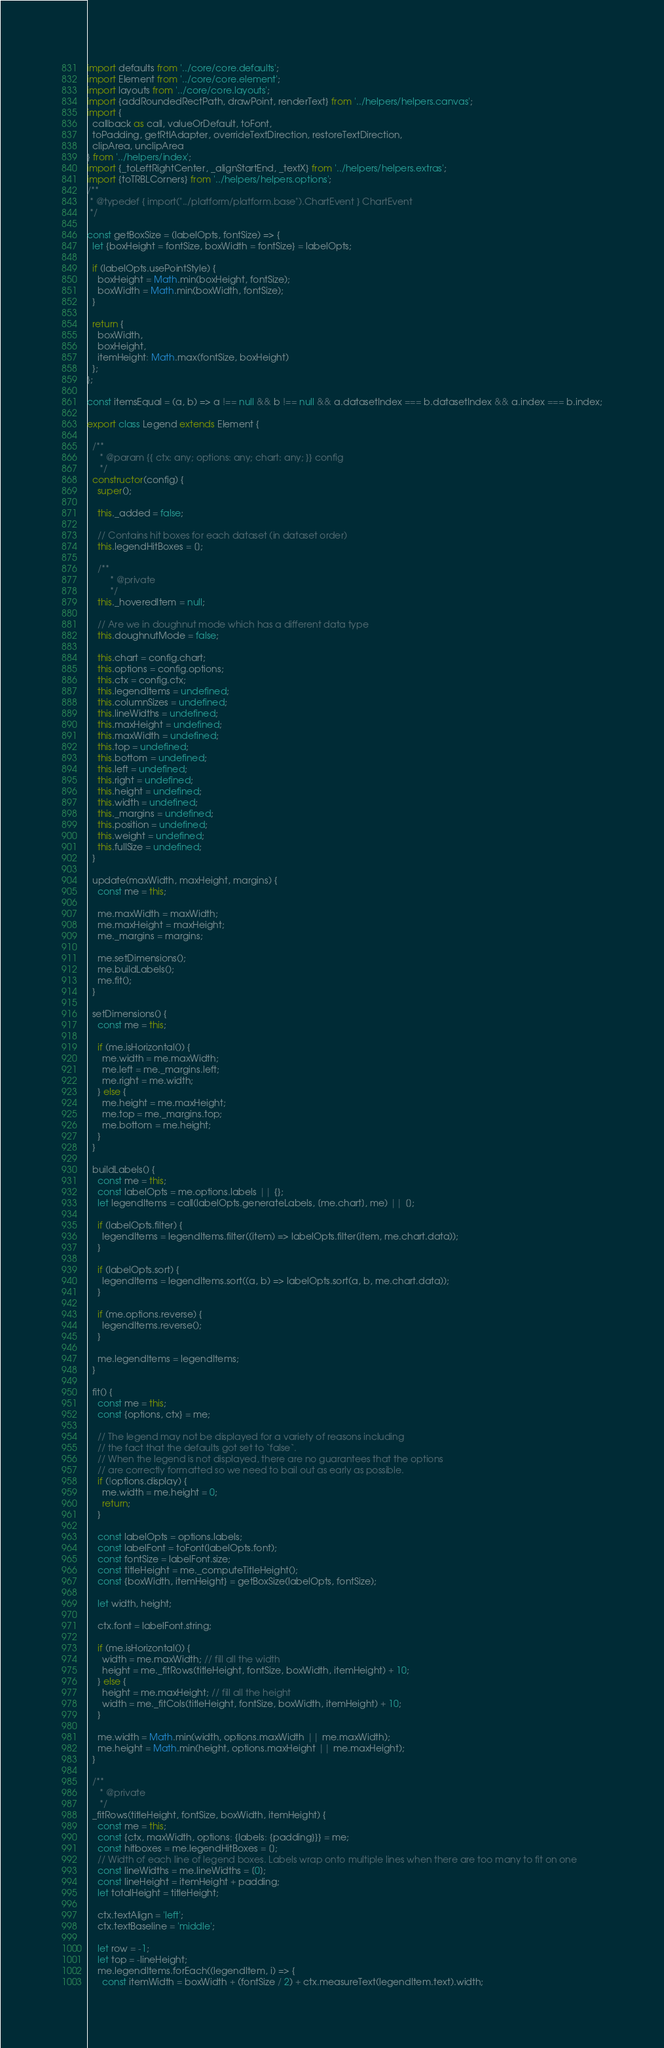<code> <loc_0><loc_0><loc_500><loc_500><_JavaScript_>import defaults from '../core/core.defaults';
import Element from '../core/core.element';
import layouts from '../core/core.layouts';
import {addRoundedRectPath, drawPoint, renderText} from '../helpers/helpers.canvas';
import {
  callback as call, valueOrDefault, toFont,
  toPadding, getRtlAdapter, overrideTextDirection, restoreTextDirection,
  clipArea, unclipArea
} from '../helpers/index';
import {_toLeftRightCenter, _alignStartEnd, _textX} from '../helpers/helpers.extras';
import {toTRBLCorners} from '../helpers/helpers.options';
/**
 * @typedef { import("../platform/platform.base").ChartEvent } ChartEvent
 */

const getBoxSize = (labelOpts, fontSize) => {
  let {boxHeight = fontSize, boxWidth = fontSize} = labelOpts;

  if (labelOpts.usePointStyle) {
    boxHeight = Math.min(boxHeight, fontSize);
    boxWidth = Math.min(boxWidth, fontSize);
  }

  return {
    boxWidth,
    boxHeight,
    itemHeight: Math.max(fontSize, boxHeight)
  };
};

const itemsEqual = (a, b) => a !== null && b !== null && a.datasetIndex === b.datasetIndex && a.index === b.index;

export class Legend extends Element {

  /**
	 * @param {{ ctx: any; options: any; chart: any; }} config
	 */
  constructor(config) {
    super();

    this._added = false;

    // Contains hit boxes for each dataset (in dataset order)
    this.legendHitBoxes = [];

    /**
 		 * @private
 		 */
    this._hoveredItem = null;

    // Are we in doughnut mode which has a different data type
    this.doughnutMode = false;

    this.chart = config.chart;
    this.options = config.options;
    this.ctx = config.ctx;
    this.legendItems = undefined;
    this.columnSizes = undefined;
    this.lineWidths = undefined;
    this.maxHeight = undefined;
    this.maxWidth = undefined;
    this.top = undefined;
    this.bottom = undefined;
    this.left = undefined;
    this.right = undefined;
    this.height = undefined;
    this.width = undefined;
    this._margins = undefined;
    this.position = undefined;
    this.weight = undefined;
    this.fullSize = undefined;
  }

  update(maxWidth, maxHeight, margins) {
    const me = this;

    me.maxWidth = maxWidth;
    me.maxHeight = maxHeight;
    me._margins = margins;

    me.setDimensions();
    me.buildLabels();
    me.fit();
  }

  setDimensions() {
    const me = this;

    if (me.isHorizontal()) {
      me.width = me.maxWidth;
      me.left = me._margins.left;
      me.right = me.width;
    } else {
      me.height = me.maxHeight;
      me.top = me._margins.top;
      me.bottom = me.height;
    }
  }

  buildLabels() {
    const me = this;
    const labelOpts = me.options.labels || {};
    let legendItems = call(labelOpts.generateLabels, [me.chart], me) || [];

    if (labelOpts.filter) {
      legendItems = legendItems.filter((item) => labelOpts.filter(item, me.chart.data));
    }

    if (labelOpts.sort) {
      legendItems = legendItems.sort((a, b) => labelOpts.sort(a, b, me.chart.data));
    }

    if (me.options.reverse) {
      legendItems.reverse();
    }

    me.legendItems = legendItems;
  }

  fit() {
    const me = this;
    const {options, ctx} = me;

    // The legend may not be displayed for a variety of reasons including
    // the fact that the defaults got set to `false`.
    // When the legend is not displayed, there are no guarantees that the options
    // are correctly formatted so we need to bail out as early as possible.
    if (!options.display) {
      me.width = me.height = 0;
      return;
    }

    const labelOpts = options.labels;
    const labelFont = toFont(labelOpts.font);
    const fontSize = labelFont.size;
    const titleHeight = me._computeTitleHeight();
    const {boxWidth, itemHeight} = getBoxSize(labelOpts, fontSize);

    let width, height;

    ctx.font = labelFont.string;

    if (me.isHorizontal()) {
      width = me.maxWidth; // fill all the width
      height = me._fitRows(titleHeight, fontSize, boxWidth, itemHeight) + 10;
    } else {
      height = me.maxHeight; // fill all the height
      width = me._fitCols(titleHeight, fontSize, boxWidth, itemHeight) + 10;
    }

    me.width = Math.min(width, options.maxWidth || me.maxWidth);
    me.height = Math.min(height, options.maxHeight || me.maxHeight);
  }

  /**
	 * @private
	 */
  _fitRows(titleHeight, fontSize, boxWidth, itemHeight) {
    const me = this;
    const {ctx, maxWidth, options: {labels: {padding}}} = me;
    const hitboxes = me.legendHitBoxes = [];
    // Width of each line of legend boxes. Labels wrap onto multiple lines when there are too many to fit on one
    const lineWidths = me.lineWidths = [0];
    const lineHeight = itemHeight + padding;
    let totalHeight = titleHeight;

    ctx.textAlign = 'left';
    ctx.textBaseline = 'middle';

    let row = -1;
    let top = -lineHeight;
    me.legendItems.forEach((legendItem, i) => {
      const itemWidth = boxWidth + (fontSize / 2) + ctx.measureText(legendItem.text).width;
</code> 